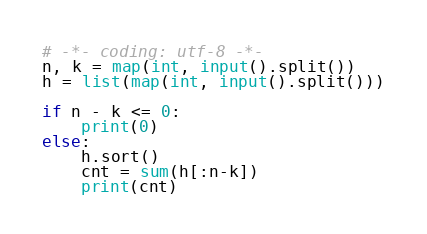<code> <loc_0><loc_0><loc_500><loc_500><_Python_># -*- coding: utf-8 -*-
n, k = map(int, input().split())
h = list(map(int, input().split()))

if n - k <= 0:
    print(0)
else:
    h.sort()
    cnt = sum(h[:n-k])
    print(cnt)
</code> 